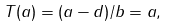<formula> <loc_0><loc_0><loc_500><loc_500>T ( a ) = ( a - d ) / b = a ,</formula> 